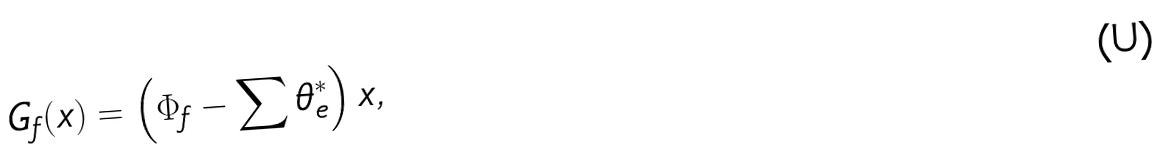Convert formula to latex. <formula><loc_0><loc_0><loc_500><loc_500>G _ { f } ( x ) = \left ( \Phi _ { f } - \sum \theta ^ { * } _ { e } \right ) x ,</formula> 